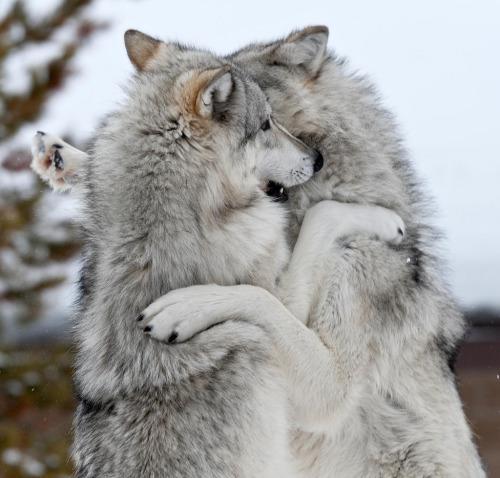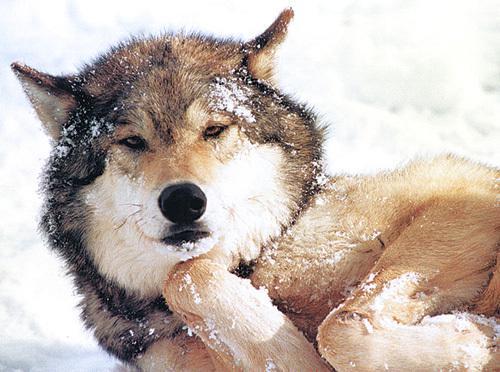The first image is the image on the left, the second image is the image on the right. Given the left and right images, does the statement "The wild dog in one of the images is lying down." hold true? Answer yes or no. Yes. The first image is the image on the left, the second image is the image on the right. Evaluate the accuracy of this statement regarding the images: "An image shows a wolf with a dusting of snow on its fur.". Is it true? Answer yes or no. Yes. 